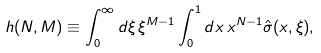Convert formula to latex. <formula><loc_0><loc_0><loc_500><loc_500>h ( N , M ) \equiv \int _ { 0 } ^ { \infty } d \xi \, \xi ^ { M - 1 } \int _ { 0 } ^ { 1 } d x \, x ^ { N - 1 } \hat { \sigma } ( x , \xi ) ,</formula> 